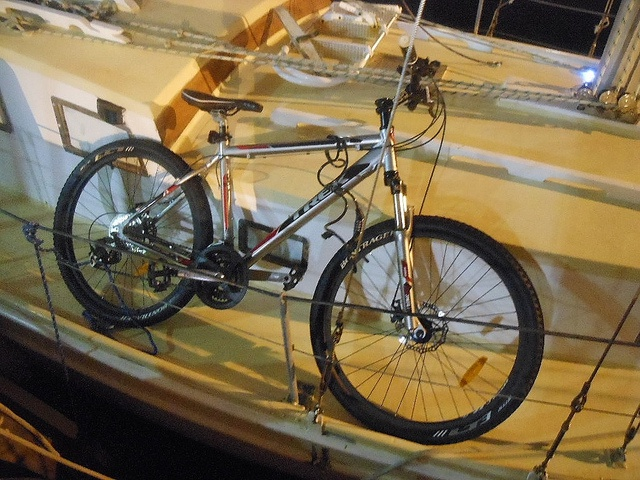Describe the objects in this image and their specific colors. I can see boat in black, tan, gray, and olive tones and bicycle in tan, black, darkgray, gray, and olive tones in this image. 